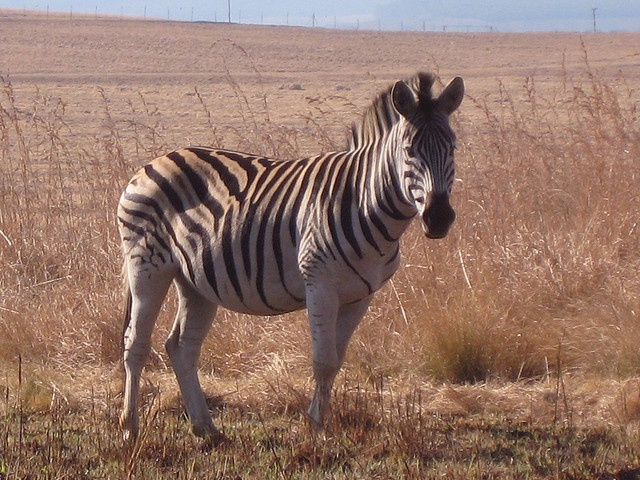Describe the objects in this image and their specific colors. I can see a zebra in lightblue, gray, black, and maroon tones in this image. 